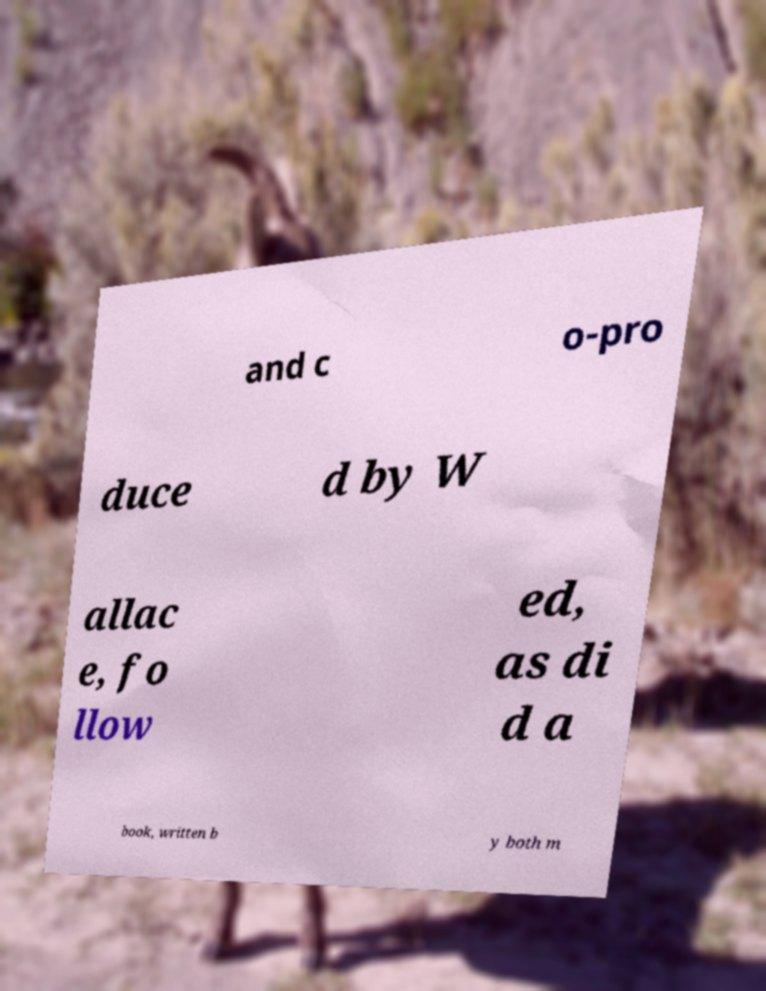Can you accurately transcribe the text from the provided image for me? and c o-pro duce d by W allac e, fo llow ed, as di d a book, written b y both m 